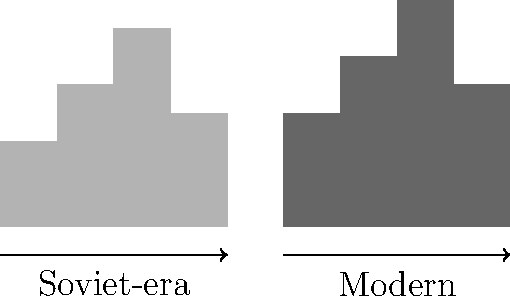Based on the before-and-after skyline diagrams representing Soviet-era and modern Ukrainian urban planning, which architectural characteristic has been most significantly altered in the transition to contemporary design? To answer this question, we need to analyze the key differences between the Soviet-era and modern skylines:

1. Building Heights:
   - Soviet-era: Mostly uniform, with a maximum height around 70% of the diagram.
   - Modern: More varied, with taller buildings reaching about 80% of the diagram height.

2. Skyline Uniformity:
   - Soviet-era: Relatively uniform, with regular, block-like structures.
   - Modern: More diverse, with varying building heights creating a jagged skyline.

3. Building Density:
   - Soviet-era: Evenly spaced buildings with similar widths.
   - Modern: Varied spacing and building widths, suggesting a mix of structure types.

4. Architectural Diversity:
   - Soviet-era: Limited variation in building shapes, indicating standardized designs.
   - Modern: Greater variation in building profiles, suggesting more architectural freedom.

The most significant change appears to be the shift from a uniform, standardized skyline to a more diverse and varied one. This reflects a move away from the Soviet-era emphasis on uniformity and standardization towards a more individualistic, market-driven approach in modern Ukrainian urban planning.
Answer: Increased architectural diversity and skyline variation 